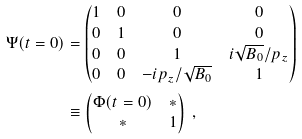<formula> <loc_0><loc_0><loc_500><loc_500>\Psi ( t = 0 ) & = \begin{pmatrix} 1 & 0 & 0 & 0 \\ 0 & 1 & 0 & 0 \\ 0 & 0 & 1 & i \sqrt { B _ { 0 } } / p _ { z } \\ 0 & 0 & - i p _ { z } / \sqrt { B _ { 0 } } & 1 \end{pmatrix} \\ & \equiv \begin{pmatrix} \Phi ( t = 0 ) & * \\ * & 1 \end{pmatrix} \ ,</formula> 